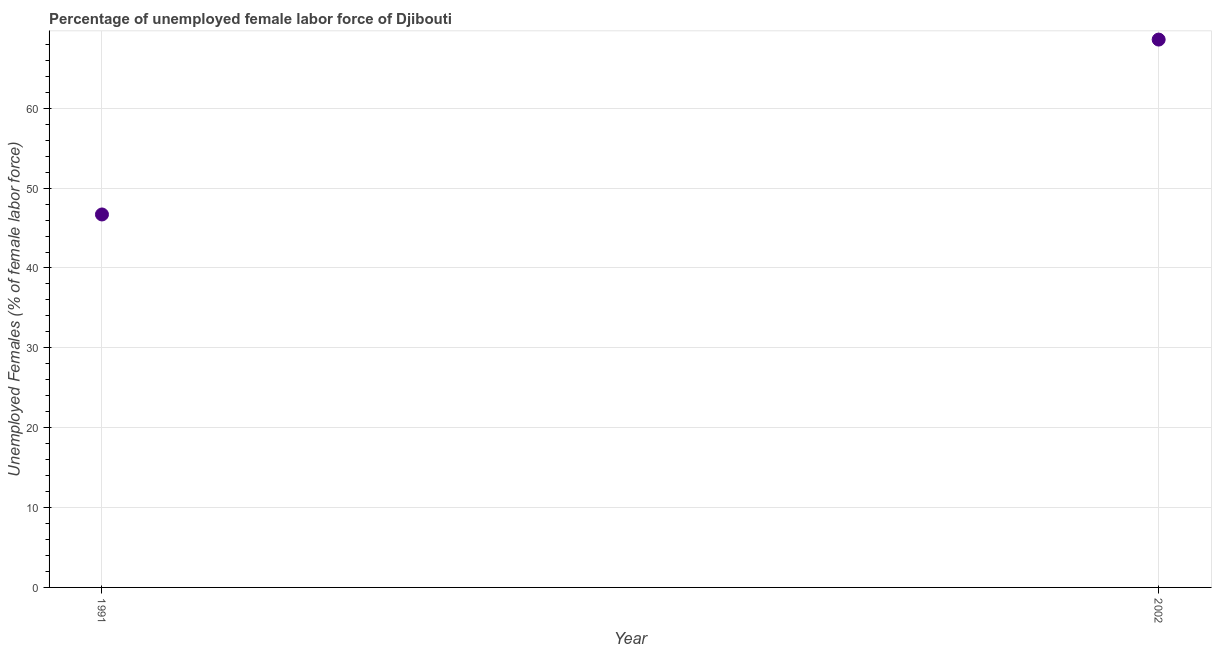What is the total unemployed female labour force in 2002?
Your answer should be very brief. 68.6. Across all years, what is the maximum total unemployed female labour force?
Provide a succinct answer. 68.6. Across all years, what is the minimum total unemployed female labour force?
Your answer should be compact. 46.7. In which year was the total unemployed female labour force maximum?
Offer a terse response. 2002. What is the sum of the total unemployed female labour force?
Provide a succinct answer. 115.3. What is the difference between the total unemployed female labour force in 1991 and 2002?
Make the answer very short. -21.9. What is the average total unemployed female labour force per year?
Offer a terse response. 57.65. What is the median total unemployed female labour force?
Provide a succinct answer. 57.65. In how many years, is the total unemployed female labour force greater than 66 %?
Keep it short and to the point. 1. What is the ratio of the total unemployed female labour force in 1991 to that in 2002?
Keep it short and to the point. 0.68. Does the total unemployed female labour force monotonically increase over the years?
Your answer should be compact. Yes. How many years are there in the graph?
Keep it short and to the point. 2. What is the difference between two consecutive major ticks on the Y-axis?
Your response must be concise. 10. Are the values on the major ticks of Y-axis written in scientific E-notation?
Provide a succinct answer. No. What is the title of the graph?
Your response must be concise. Percentage of unemployed female labor force of Djibouti. What is the label or title of the Y-axis?
Your answer should be compact. Unemployed Females (% of female labor force). What is the Unemployed Females (% of female labor force) in 1991?
Provide a short and direct response. 46.7. What is the Unemployed Females (% of female labor force) in 2002?
Your answer should be compact. 68.6. What is the difference between the Unemployed Females (% of female labor force) in 1991 and 2002?
Give a very brief answer. -21.9. What is the ratio of the Unemployed Females (% of female labor force) in 1991 to that in 2002?
Keep it short and to the point. 0.68. 